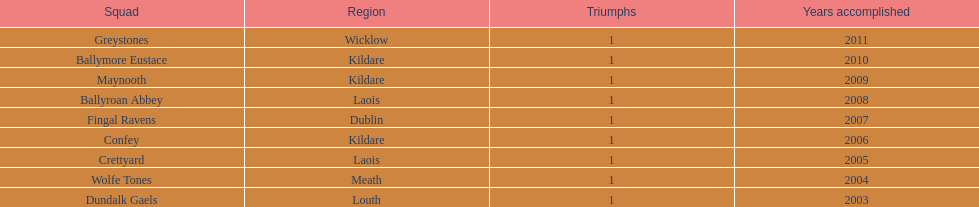Which county had the most number of wins? Kildare. 